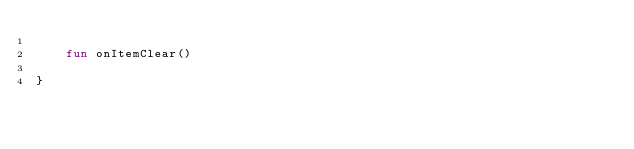<code> <loc_0><loc_0><loc_500><loc_500><_Kotlin_>
    fun onItemClear()

}
</code> 